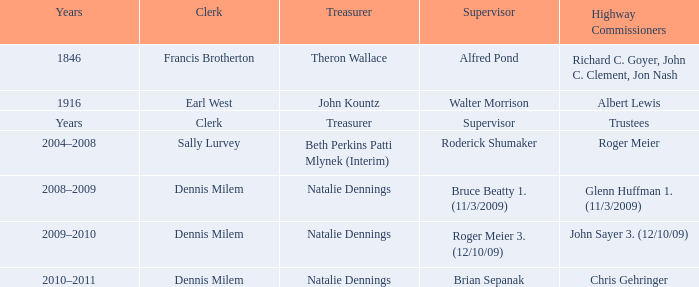Who was the supervisor in the year 1846? Alfred Pond. 